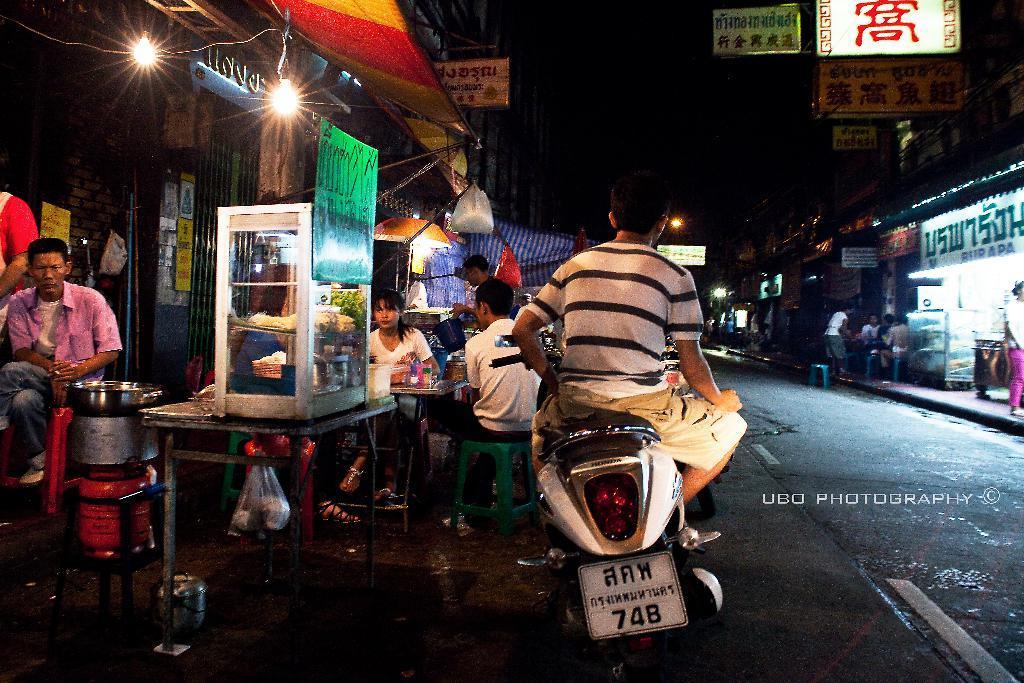Can you describe this image briefly? this is the image of the street with the street food centers and there is a person sitting in the scooter and there are few people sitting on a table eating the food and their a tent at the top and some name boards and a stove to cook food and some food preserved in the glass box. 